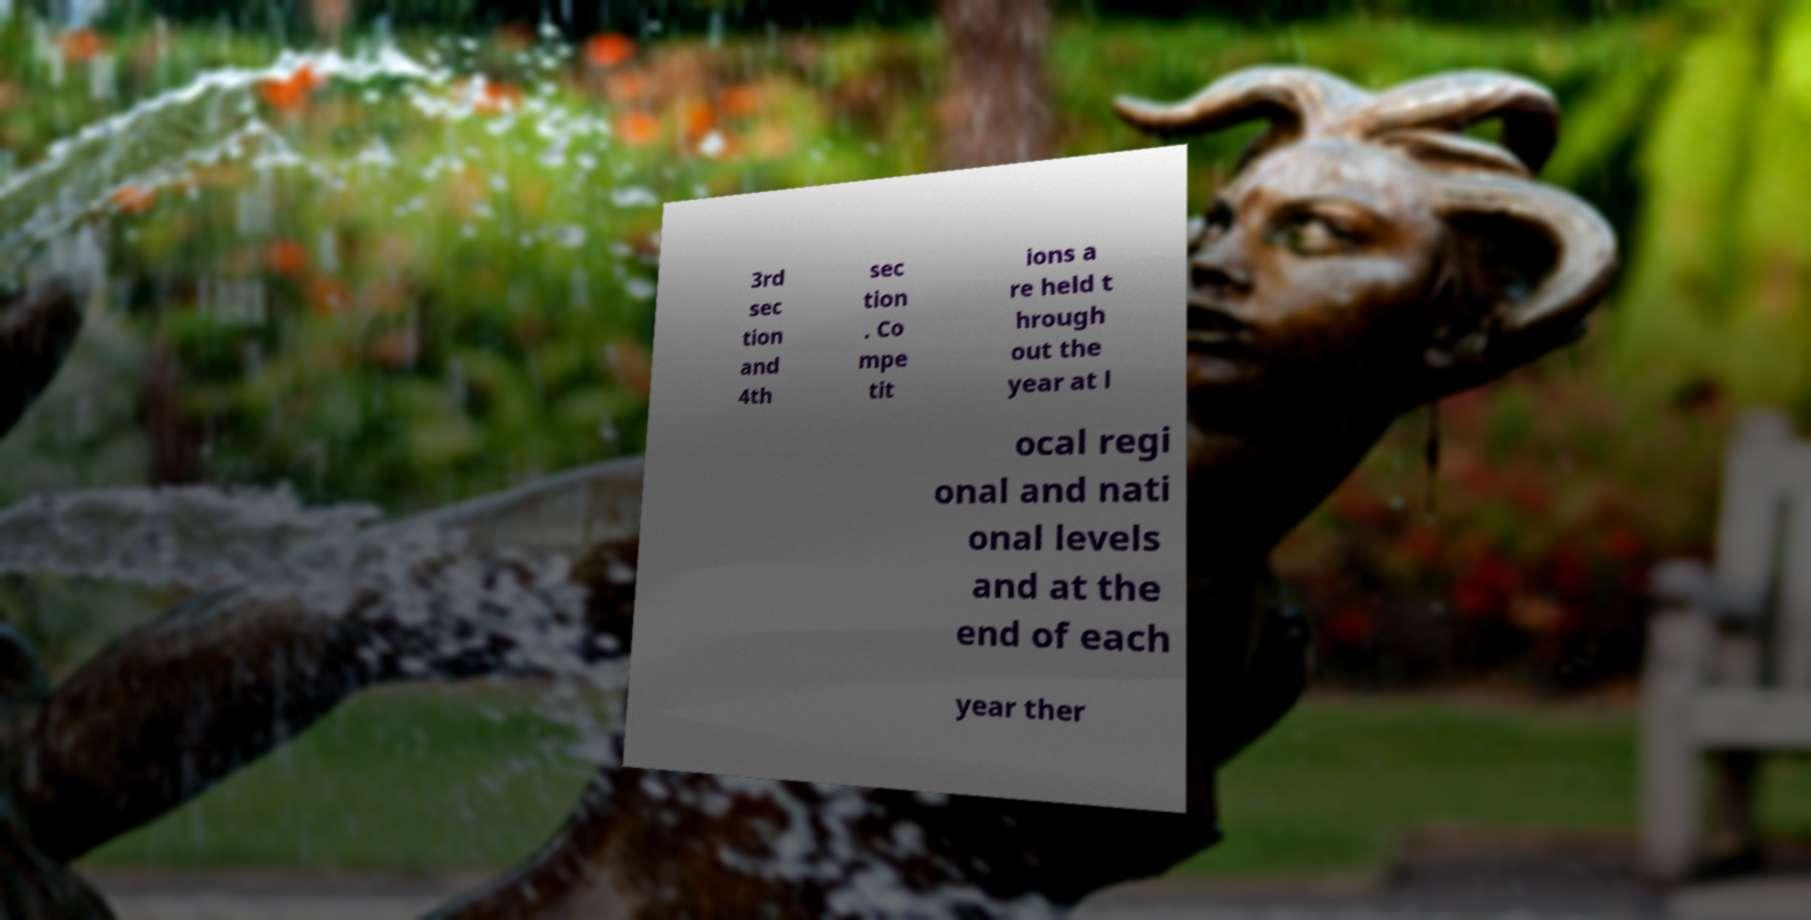Please read and relay the text visible in this image. What does it say? 3rd sec tion and 4th sec tion . Co mpe tit ions a re held t hrough out the year at l ocal regi onal and nati onal levels and at the end of each year ther 